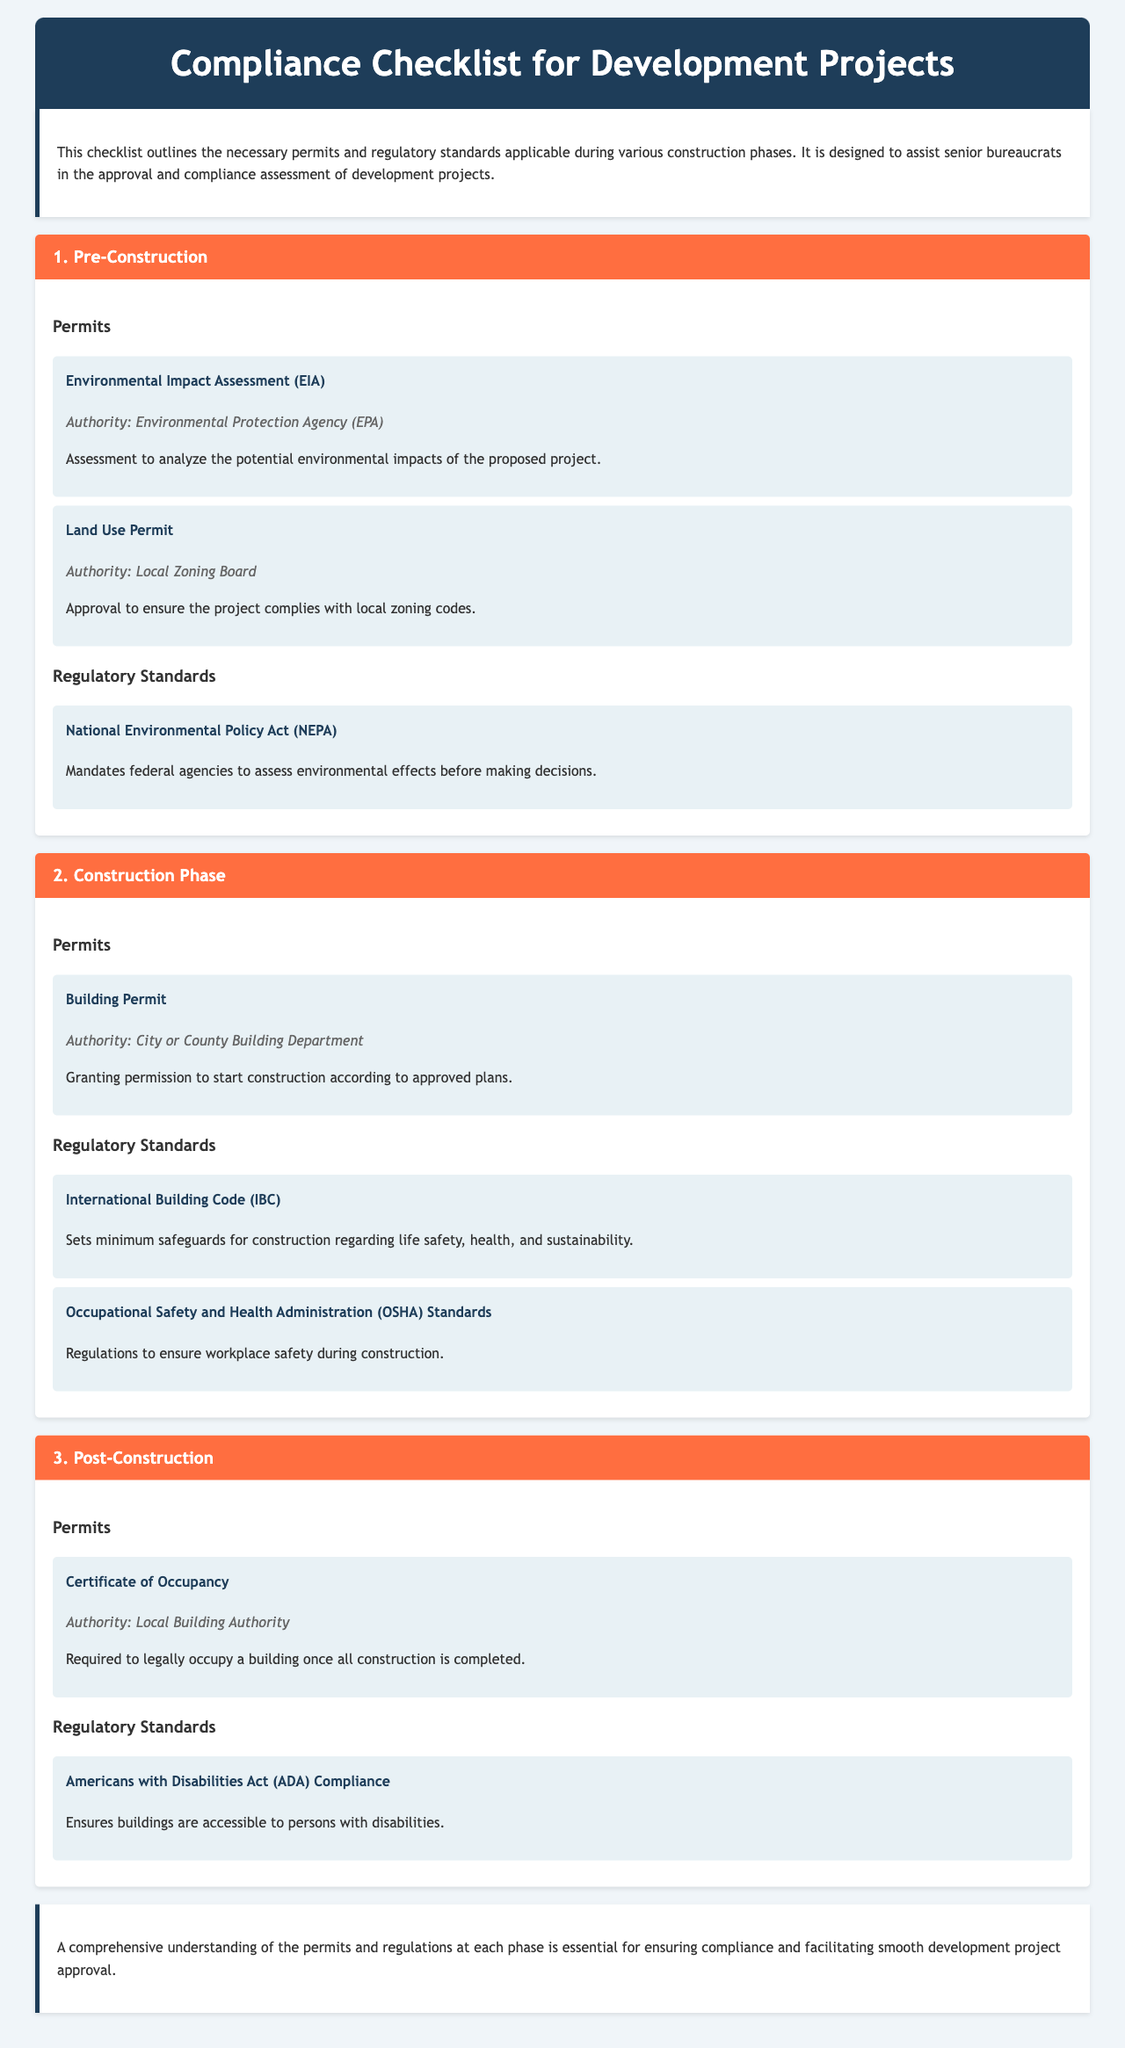What is the first permit listed in the Pre-Construction phase? The first permit listed in the Pre-Construction phase is an Environmental Impact Assessment (EIA).
Answer: Environmental Impact Assessment (EIA) Who authorizes the Land Use Permit? The authority that issues the Land Use Permit is the Local Zoning Board.
Answer: Local Zoning Board What is the primary regulatory standard during the Construction Phase? The primary regulatory standard listed for the Construction Phase is the International Building Code (IBC).
Answer: International Building Code (IBC) What is required before occupying a building post-construction? A Certificate of Occupancy is required to legally occupy a building once all construction is completed.
Answer: Certificate of Occupancy How many regulatory standards are mentioned in the Construction Phase? There are two regulatory standards mentioned during the Construction Phase.
Answer: 2 Which authority issues the Certificate of Occupancy? The authority that issues the Certificate of Occupancy is the Local Building Authority.
Answer: Local Building Authority What does the Americans with Disabilities Act (ADA) Compliance ensure? The Americans with Disabilities Act (ADA) Compliance ensures buildings are accessible to persons with disabilities.
Answer: Accessible to persons with disabilities What is the purpose of the Environmental Impact Assessment (EIA)? The purpose of the Environmental Impact Assessment (EIA) is to analyze the potential environmental impacts of the proposed project.
Answer: Analyze potential environmental impacts During which phase is the Building Permit required? The Building Permit is required during the Construction Phase.
Answer: Construction Phase 